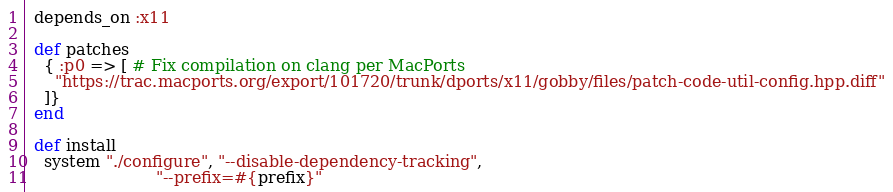<code> <loc_0><loc_0><loc_500><loc_500><_Ruby_>  depends_on :x11

  def patches
    { :p0 => [ # Fix compilation on clang per MacPorts
      "https://trac.macports.org/export/101720/trunk/dports/x11/gobby/files/patch-code-util-config.hpp.diff"
    ]}
  end

  def install
    system "./configure", "--disable-dependency-tracking",
                          "--prefix=#{prefix}"</code> 